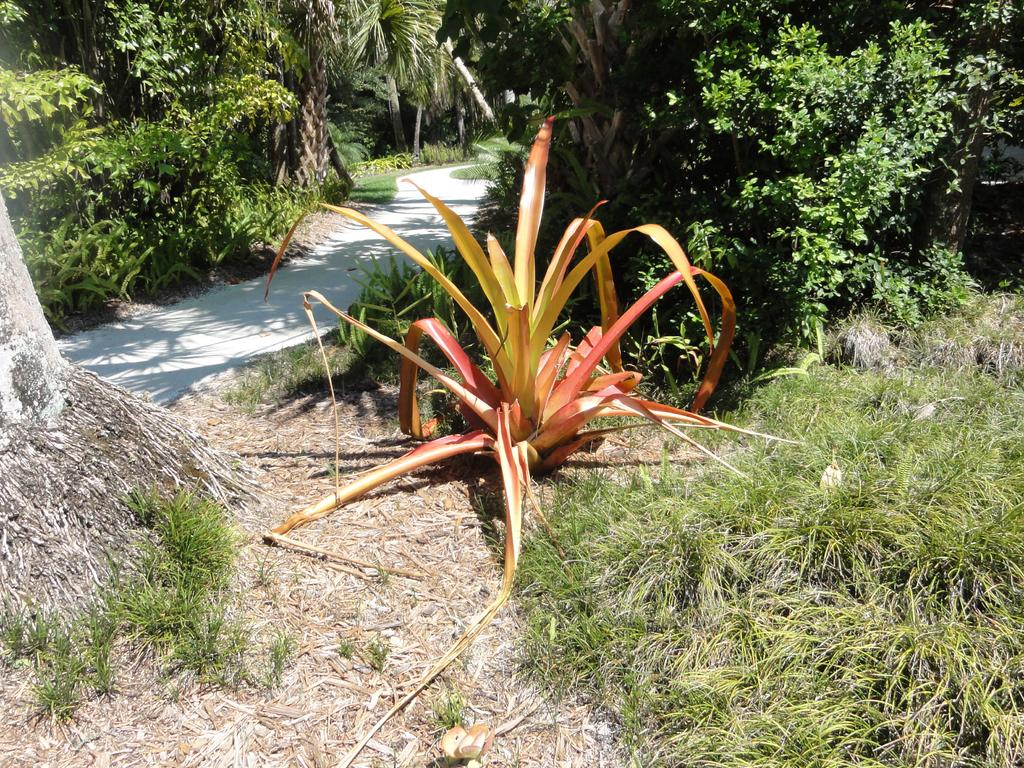What type of vegetation can be seen in the image? There are plants and trees in the image. Can you describe the specific types of plants or trees? Unfortunately, the facts provided do not specify the types of plants or trees in the image. What is the setting or environment in which the plants and trees are located? The facts do not specify the setting or environment of the plants and trees. What is the belief system of the plants in the image? Plants do not have belief systems, as they are living organisms and not capable of holding beliefs. 